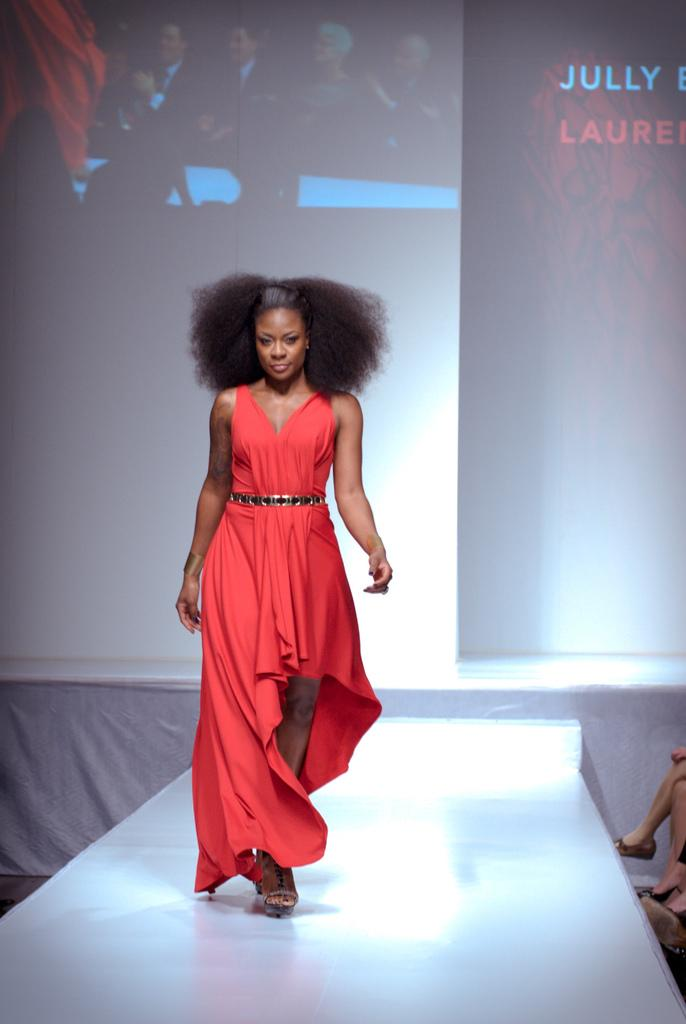Who is the main subject in the image? There is a woman in the image. What is the woman doing in the image? The woman is walking on a ramp. What can be seen in the background of the image? There is a screen visible in the background of the image. How does the wind affect the woman's walk on the ramp in the image? There is no mention of wind in the image, so we cannot determine its effect on the woman's walk. 